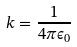Convert formula to latex. <formula><loc_0><loc_0><loc_500><loc_500>k = \frac { 1 } { 4 \pi \epsilon _ { 0 } }</formula> 